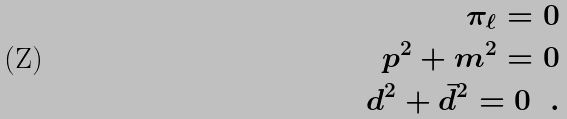<formula> <loc_0><loc_0><loc_500><loc_500>\pi _ { \ell } = 0 \\ p ^ { 2 } + m ^ { 2 } = 0 \\ d ^ { 2 } + \bar { d } ^ { 2 } = 0 \ \ .</formula> 